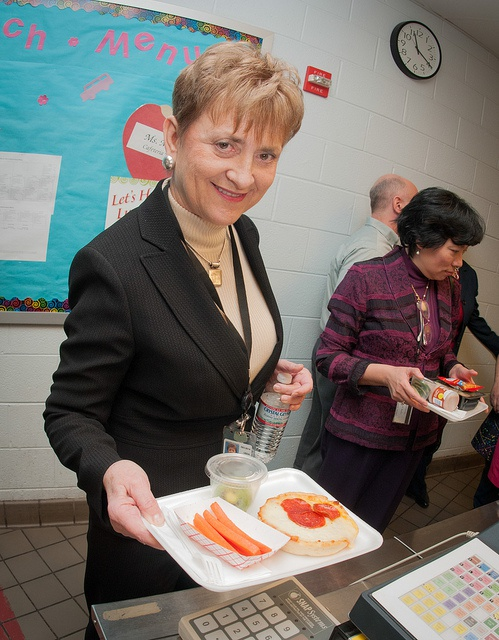Describe the objects in this image and their specific colors. I can see people in gray, black, tan, and salmon tones, people in gray, black, maroon, purple, and brown tones, dining table in gray and maroon tones, bowl in gray, lightgray, salmon, lightpink, and red tones, and pizza in gray, tan, beige, red, and orange tones in this image. 